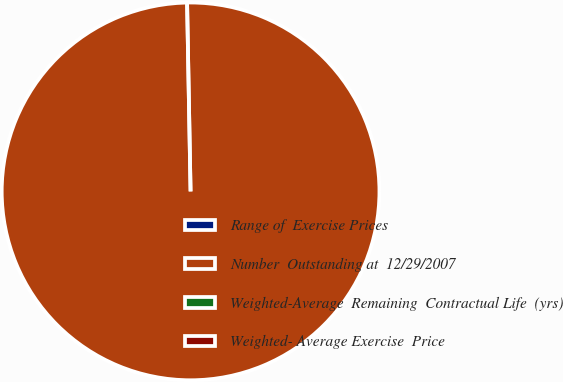<chart> <loc_0><loc_0><loc_500><loc_500><pie_chart><fcel>Range of  Exercise Prices<fcel>Number  Outstanding at  12/29/2007<fcel>Weighted-Average  Remaining  Contractual Life  (yrs)<fcel>Weighted- Average Exercise  Price<nl><fcel>0.0%<fcel>100.0%<fcel>0.0%<fcel>0.0%<nl></chart> 